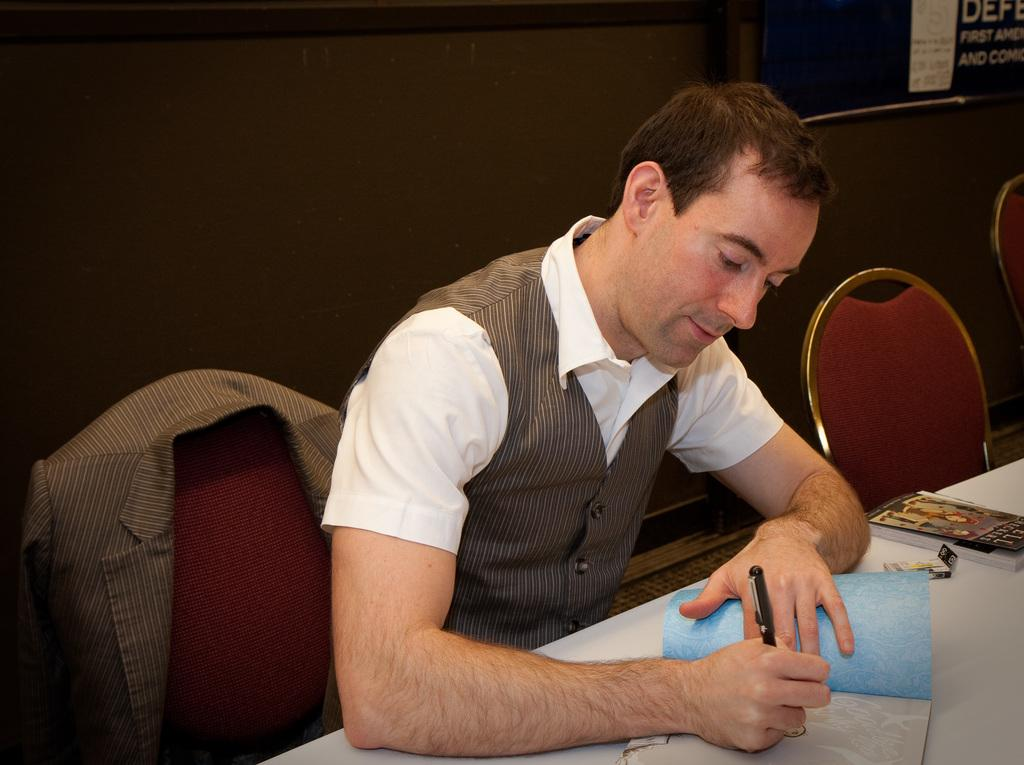What is the person in the image doing? The person is sitting on a chair and writing on a book. What is the person holding in the image? The person is holding a pen. What can be seen in front of the table in the image? There are chairs in front of the table. What type of house is depicted in the image? There is no house depicted in the image; it features a person sitting on a chair and writing on a book. What story is the person telling in the image? There is no indication in the image that the person is telling a story; they are simply writing on a book. 